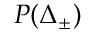<formula> <loc_0><loc_0><loc_500><loc_500>P ( \Delta _ { \pm } )</formula> 